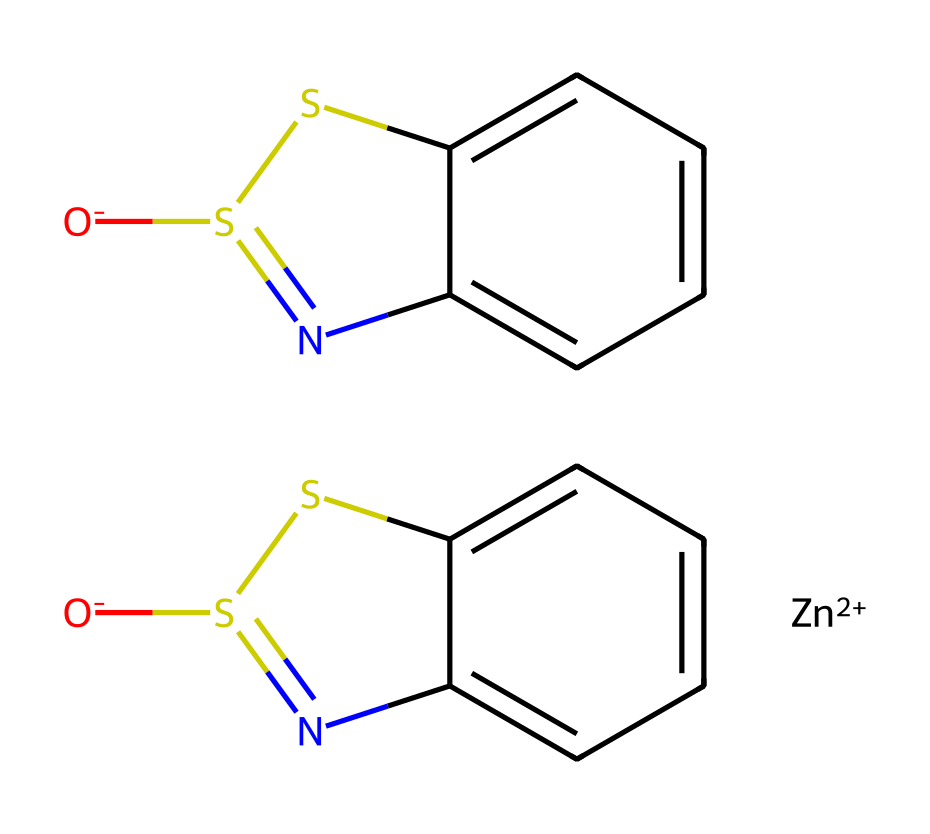What is the central metal atom in this chemical? The SMILES representation indicates the presence of a zinc ion, noted as [Zn+2], which is the central metal atom.
Answer: zinc How many sulfur atoms are present in this molecule? The structure has two sulfur atoms indicated by the [O-]S1 and S1 as part of the pyrithione structure and they are part of the repeating unit.
Answer: two What is the total number of nitrogen atoms in this chemical? The chemical contains two nitrogen atoms in the rings as denoted by the 'N' in the SMILES structure; there are two occurrences within the given representation.
Answer: two Is this chemical an organometallic compound? Yes, because it contains a metal (zinc) attached to organic components (the pyrithione structure).
Answer: yes What type of chemical bonding predominates in the non-metal portion of this molecule? The non-metal portion primarily showcases covalent bonds between carbon, nitrogen, and sulfur atoms based on their arrangements in the pyrithione structure.
Answer: covalent Does this molecule contain a functional group that may contribute to its biological activity? Yes, the thione functional group (S1= NC) and its structural makeup likely contribute to the biological activity relevant in skincare products like sunscreens.
Answer: thione 